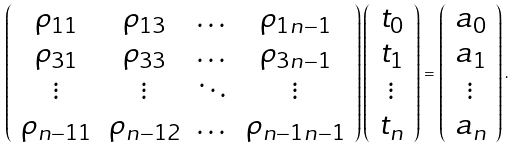<formula> <loc_0><loc_0><loc_500><loc_500>\left ( \begin{array} { c c c c } \rho _ { 1 1 } & \rho _ { 1 3 } & \dots & \rho _ { 1 n - 1 } \\ \rho _ { 3 1 } & \rho _ { 3 3 } & \dots & \rho _ { 3 n - 1 } \\ \vdots & \vdots & \ddots & \vdots \\ \rho _ { n - 1 1 } & \rho _ { n - 1 2 } & \dots & \rho _ { n - 1 n - 1 } \end{array} \right ) \left ( \begin{array} { c } t _ { 0 } \\ t _ { 1 } \\ \vdots \\ t _ { n } \end{array} \right ) = \left ( \begin{array} { c } a _ { 0 } \\ a _ { 1 } \\ \vdots \\ a _ { n } \end{array} \right ) .</formula> 